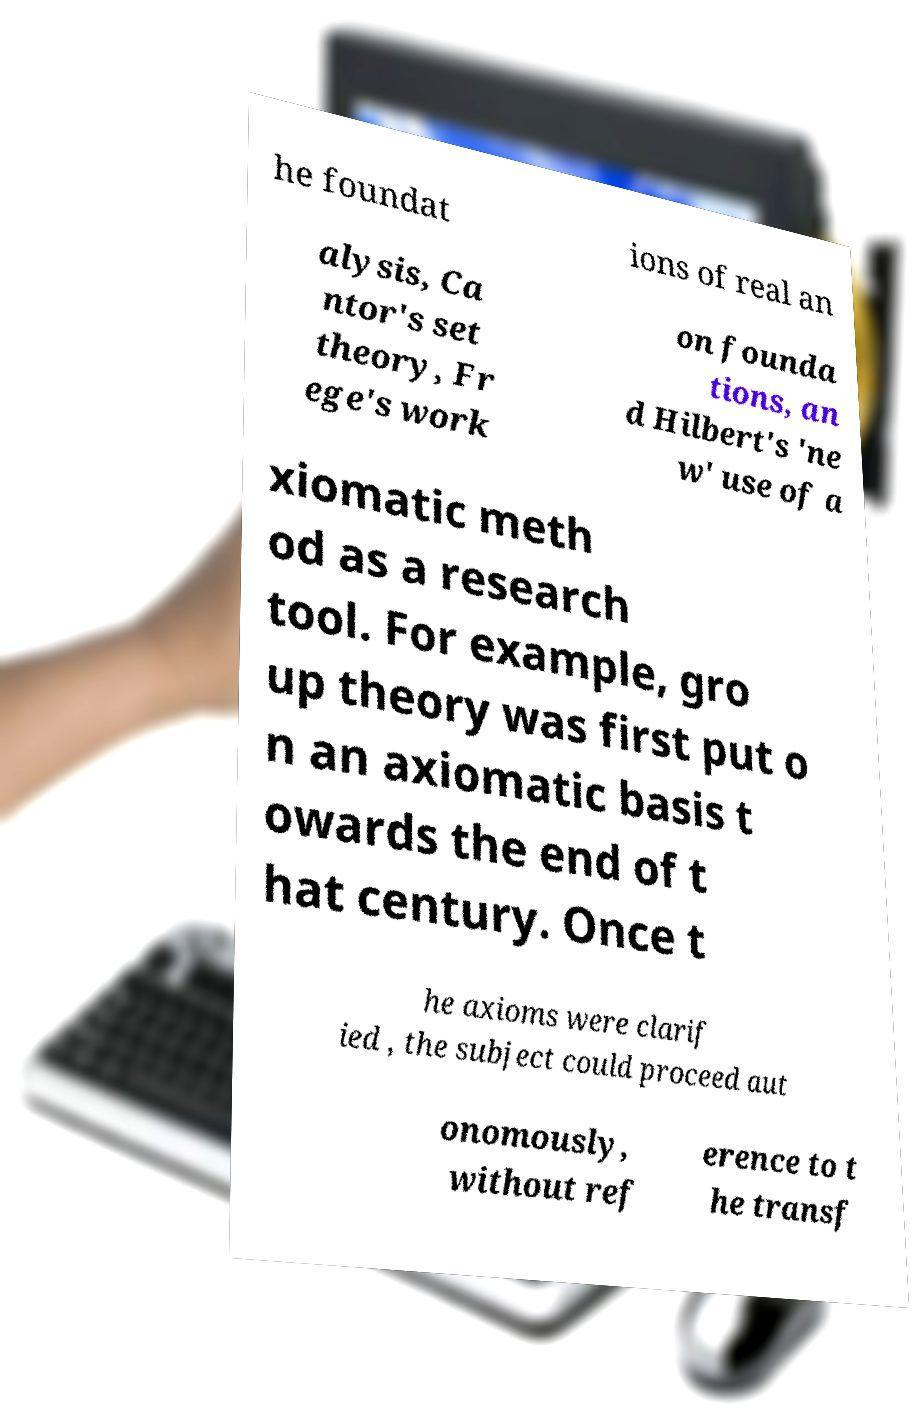Can you read and provide the text displayed in the image?This photo seems to have some interesting text. Can you extract and type it out for me? he foundat ions of real an alysis, Ca ntor's set theory, Fr ege's work on founda tions, an d Hilbert's 'ne w' use of a xiomatic meth od as a research tool. For example, gro up theory was first put o n an axiomatic basis t owards the end of t hat century. Once t he axioms were clarif ied , the subject could proceed aut onomously, without ref erence to t he transf 